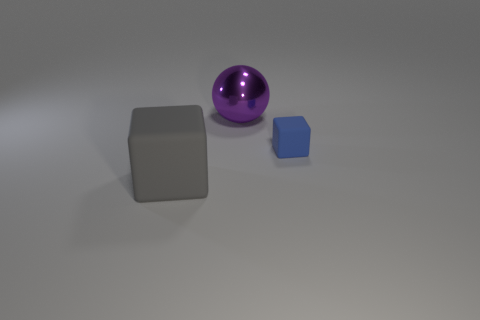There is a object that is behind the cube that is behind the cube that is to the left of the tiny cube; what is it made of? The object in question appears to be a sphere made of a shiny material, likely a polished metal or a reflective plastic, given the way it reflects light and the surroundings. 